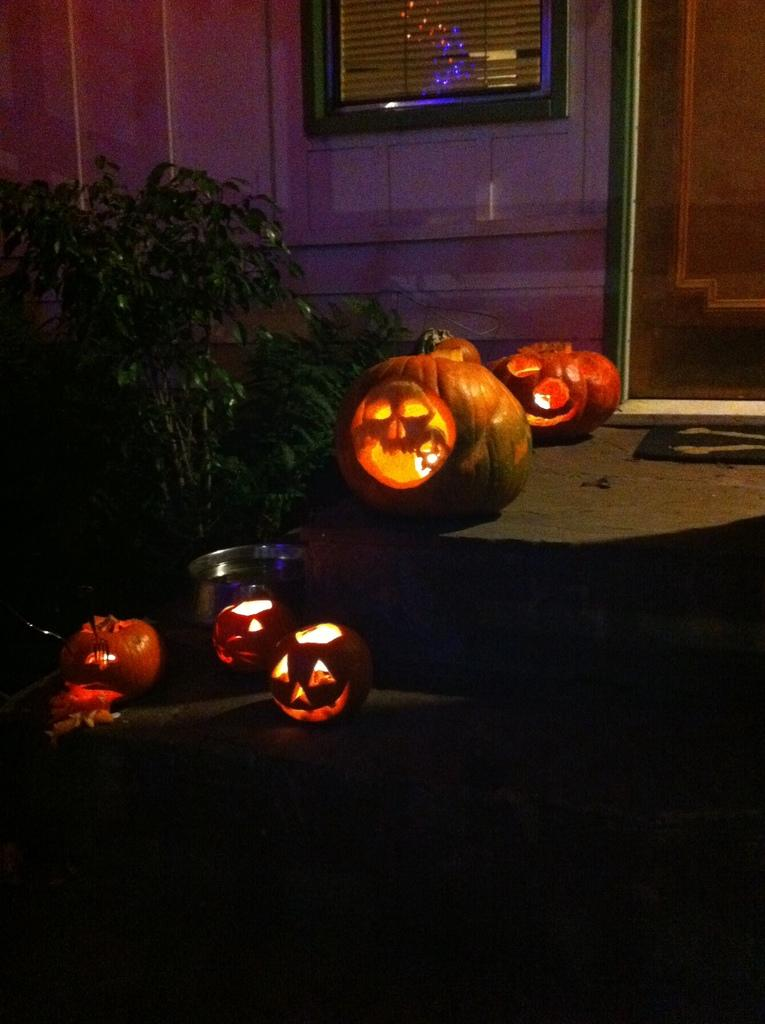What objects with lights are present in the image? There are pumpkins with lights in the image. Where are the pumpkins located? The pumpkins are on the land in the image. What else can be seen in the image besides the pumpkins? There is a vessel, plants, a wall, a door, and a window in the image. How many trucks are parked near the pumpkins in the image? There are no trucks present in the image. What type of bird can be seen sitting on the pumpkin in the image? There are no birds visible in the image, including robins. 